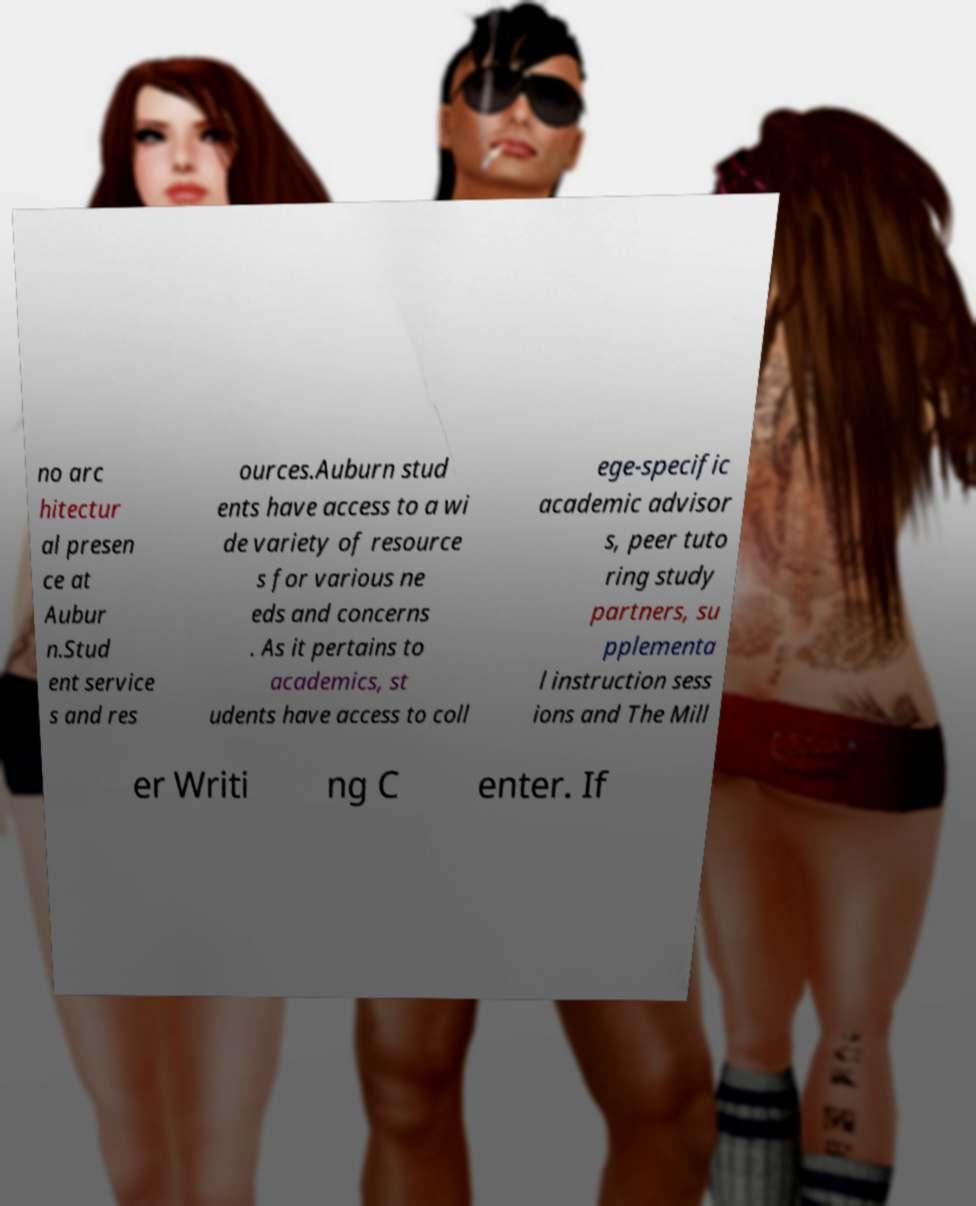For documentation purposes, I need the text within this image transcribed. Could you provide that? no arc hitectur al presen ce at Aubur n.Stud ent service s and res ources.Auburn stud ents have access to a wi de variety of resource s for various ne eds and concerns . As it pertains to academics, st udents have access to coll ege-specific academic advisor s, peer tuto ring study partners, su pplementa l instruction sess ions and The Mill er Writi ng C enter. If 